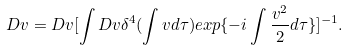Convert formula to latex. <formula><loc_0><loc_0><loc_500><loc_500>D v = D v [ \int D v \delta ^ { 4 } ( \int v d \tau ) e x p \{ - i \int \frac { v ^ { 2 } } { 2 } d \tau \} ] ^ { - 1 } .</formula> 